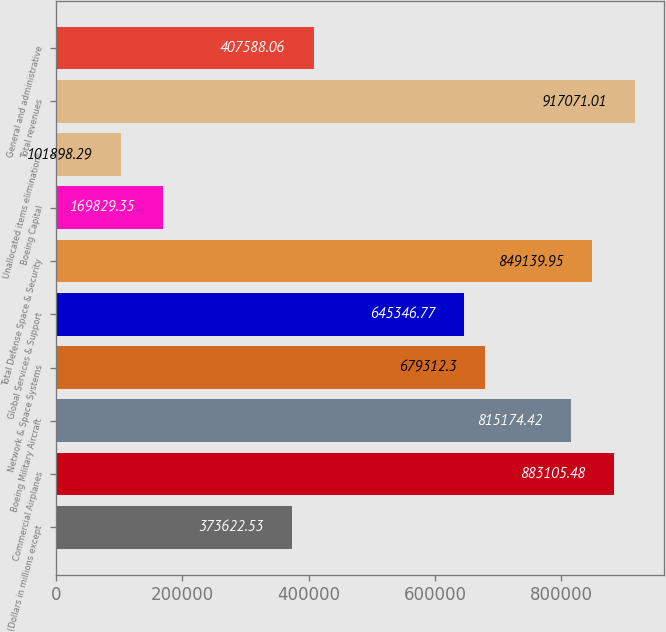Convert chart. <chart><loc_0><loc_0><loc_500><loc_500><bar_chart><fcel>(Dollars in millions except<fcel>Commercial Airplanes<fcel>Boeing Military Aircraft<fcel>Network & Space Systems<fcel>Global Services & Support<fcel>Total Defense Space & Security<fcel>Boeing Capital<fcel>Unallocated items eliminations<fcel>Total revenues<fcel>General and administrative<nl><fcel>373623<fcel>883105<fcel>815174<fcel>679312<fcel>645347<fcel>849140<fcel>169829<fcel>101898<fcel>917071<fcel>407588<nl></chart> 